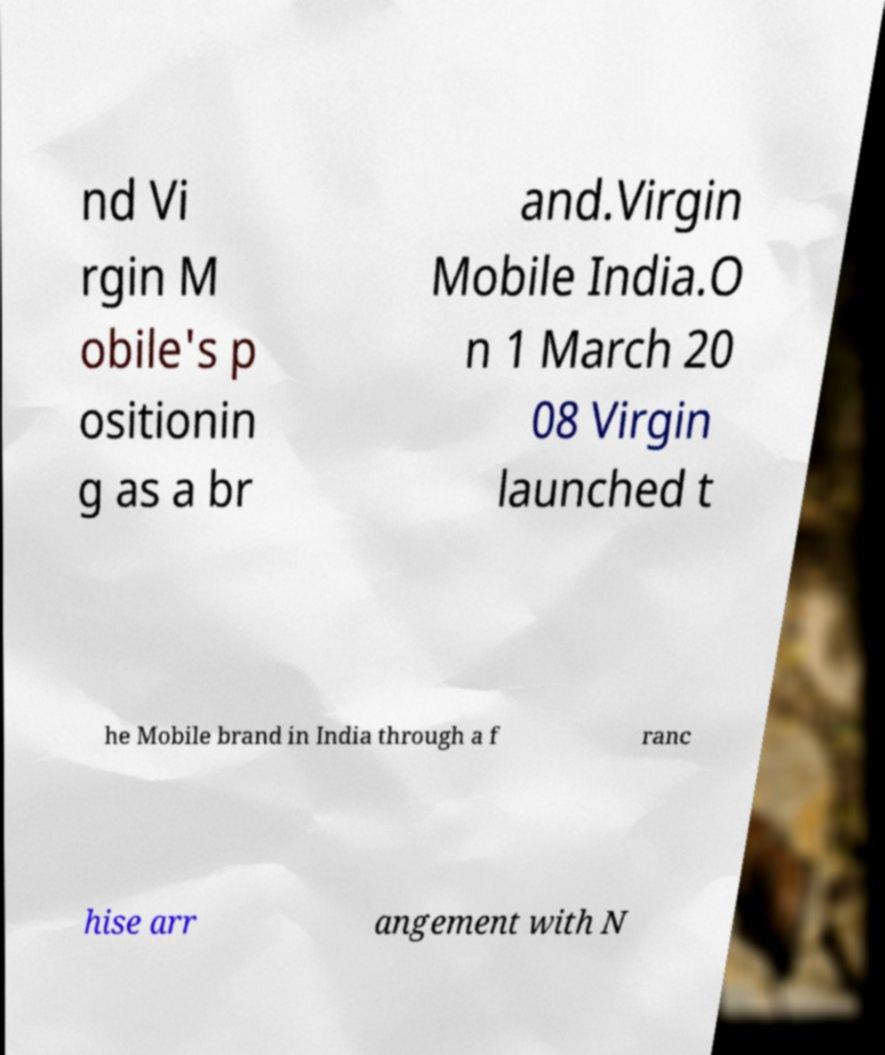I need the written content from this picture converted into text. Can you do that? nd Vi rgin M obile's p ositionin g as a br and.Virgin Mobile India.O n 1 March 20 08 Virgin launched t he Mobile brand in India through a f ranc hise arr angement with N 